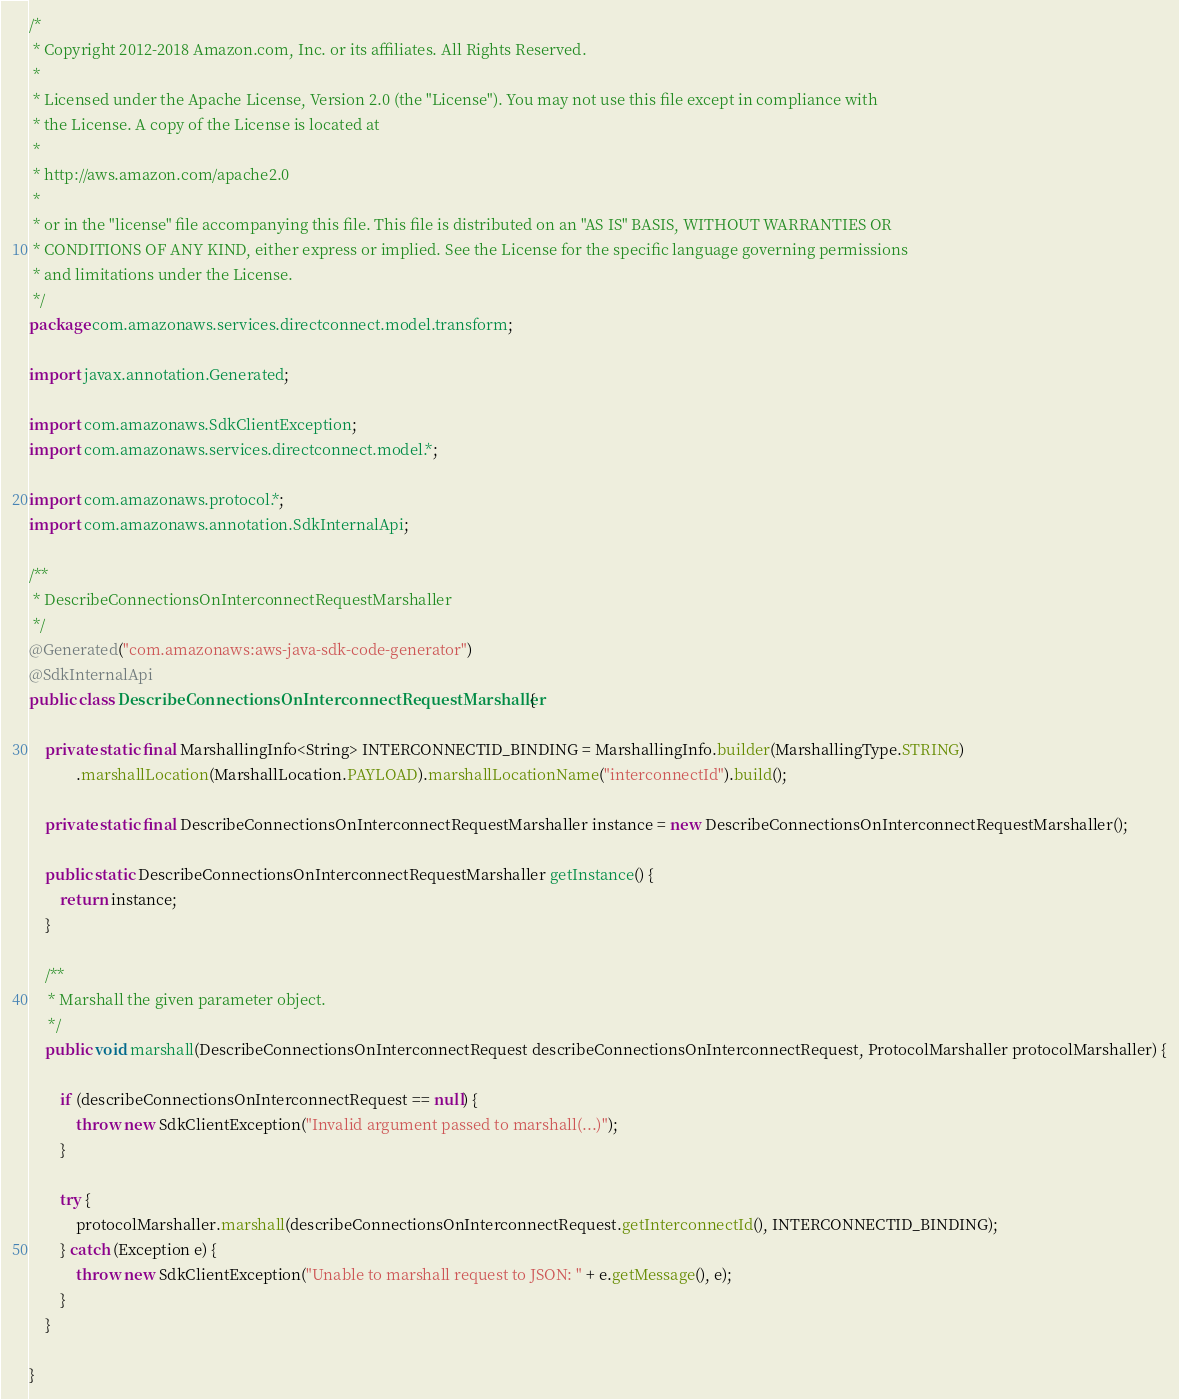Convert code to text. <code><loc_0><loc_0><loc_500><loc_500><_Java_>/*
 * Copyright 2012-2018 Amazon.com, Inc. or its affiliates. All Rights Reserved.
 * 
 * Licensed under the Apache License, Version 2.0 (the "License"). You may not use this file except in compliance with
 * the License. A copy of the License is located at
 * 
 * http://aws.amazon.com/apache2.0
 * 
 * or in the "license" file accompanying this file. This file is distributed on an "AS IS" BASIS, WITHOUT WARRANTIES OR
 * CONDITIONS OF ANY KIND, either express or implied. See the License for the specific language governing permissions
 * and limitations under the License.
 */
package com.amazonaws.services.directconnect.model.transform;

import javax.annotation.Generated;

import com.amazonaws.SdkClientException;
import com.amazonaws.services.directconnect.model.*;

import com.amazonaws.protocol.*;
import com.amazonaws.annotation.SdkInternalApi;

/**
 * DescribeConnectionsOnInterconnectRequestMarshaller
 */
@Generated("com.amazonaws:aws-java-sdk-code-generator")
@SdkInternalApi
public class DescribeConnectionsOnInterconnectRequestMarshaller {

    private static final MarshallingInfo<String> INTERCONNECTID_BINDING = MarshallingInfo.builder(MarshallingType.STRING)
            .marshallLocation(MarshallLocation.PAYLOAD).marshallLocationName("interconnectId").build();

    private static final DescribeConnectionsOnInterconnectRequestMarshaller instance = new DescribeConnectionsOnInterconnectRequestMarshaller();

    public static DescribeConnectionsOnInterconnectRequestMarshaller getInstance() {
        return instance;
    }

    /**
     * Marshall the given parameter object.
     */
    public void marshall(DescribeConnectionsOnInterconnectRequest describeConnectionsOnInterconnectRequest, ProtocolMarshaller protocolMarshaller) {

        if (describeConnectionsOnInterconnectRequest == null) {
            throw new SdkClientException("Invalid argument passed to marshall(...)");
        }

        try {
            protocolMarshaller.marshall(describeConnectionsOnInterconnectRequest.getInterconnectId(), INTERCONNECTID_BINDING);
        } catch (Exception e) {
            throw new SdkClientException("Unable to marshall request to JSON: " + e.getMessage(), e);
        }
    }

}
</code> 